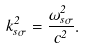Convert formula to latex. <formula><loc_0><loc_0><loc_500><loc_500>k _ { s \sigma } ^ { 2 } = \frac { \omega ^ { 2 } _ { s \sigma } } { c ^ { 2 } } .</formula> 